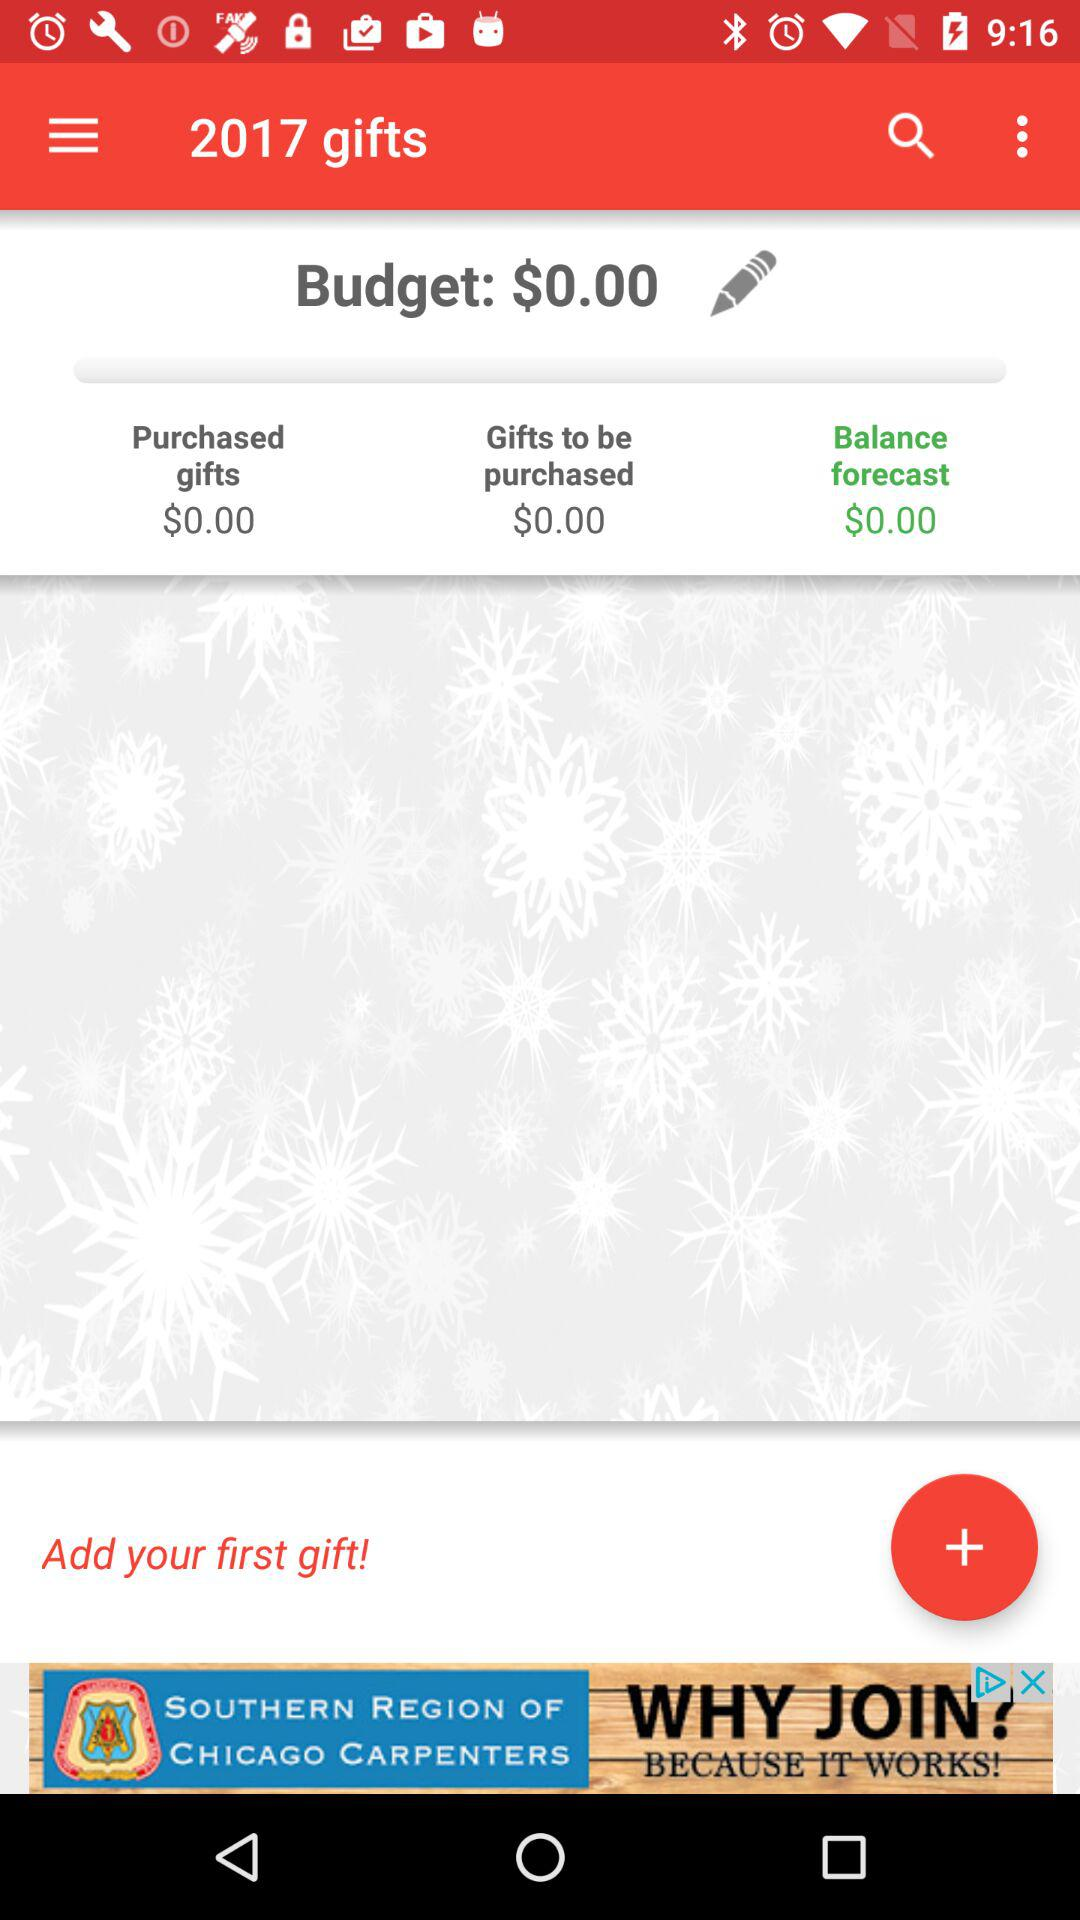How much is the total amount of gifts to be purchased?
Answer the question using a single word or phrase. $0.00 